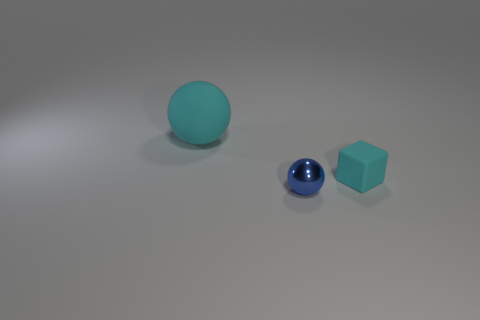Add 1 small blue things. How many objects exist? 4 Subtract all large blue things. Subtract all blue balls. How many objects are left? 2 Add 3 cyan balls. How many cyan balls are left? 4 Add 3 big cyan rubber spheres. How many big cyan rubber spheres exist? 4 Subtract 0 yellow cubes. How many objects are left? 3 Subtract all cubes. How many objects are left? 2 